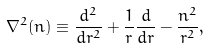Convert formula to latex. <formula><loc_0><loc_0><loc_500><loc_500>\nabla ^ { 2 } ( n ) \equiv \frac { d ^ { 2 } } { d r ^ { 2 } } + \frac { 1 } { r } \frac { d } { d r } - \frac { n ^ { 2 } } { r ^ { 2 } } ,</formula> 